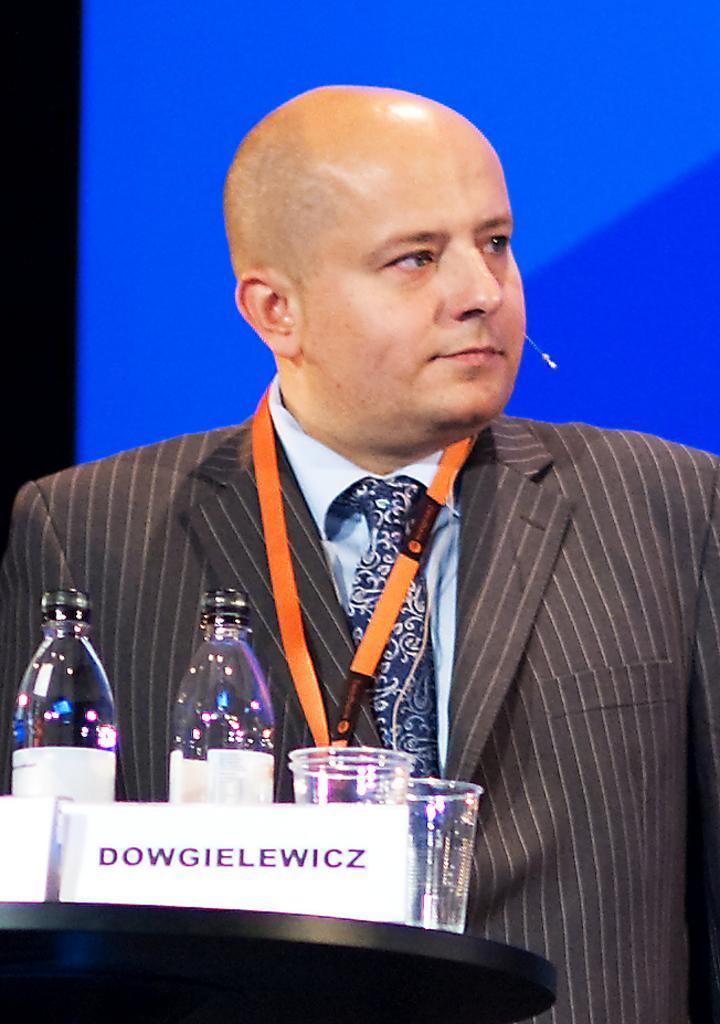How would you summarize this image in a sentence or two? In this picture we can see a man who wear a black suit. These are the bottles and glasses. 